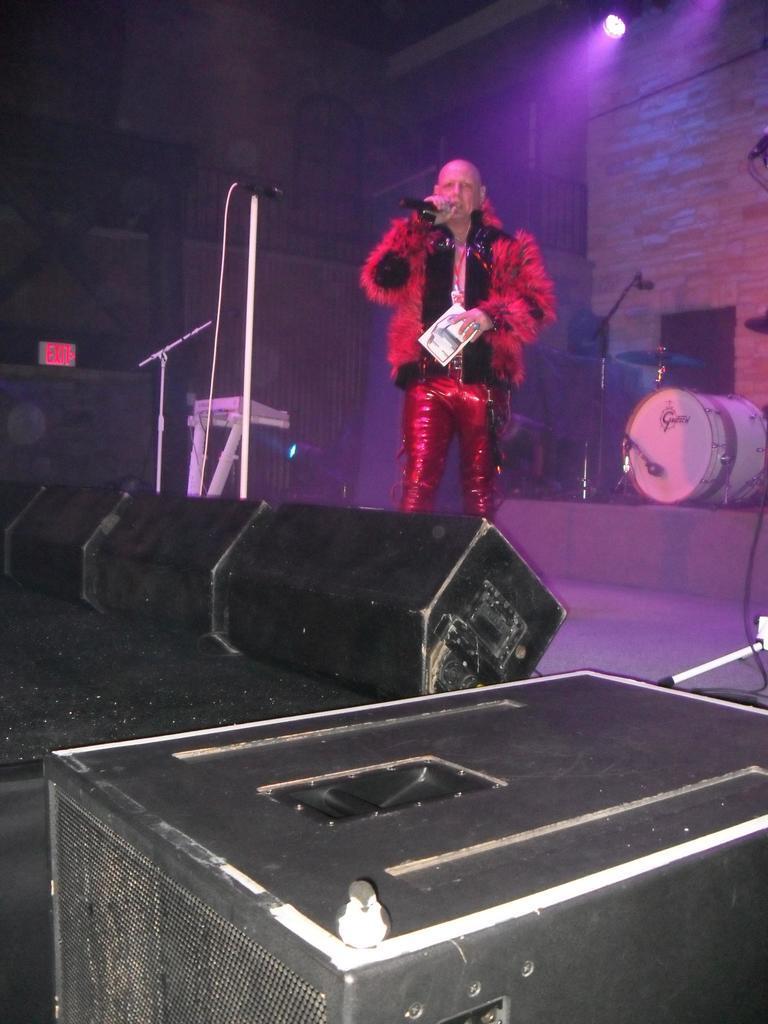Please provide a concise description of this image. Here in this picture we can see a person standing on a stage with red colored fur jacket on him over there and he is singing something with a microphone present in his hand and holding a card in other hand and behind him we can see drums and microphone and on the side we can see a piano and a microphone present over there and in the front we can see speakers present all over there and at the top we can see colorful lights present over there. 